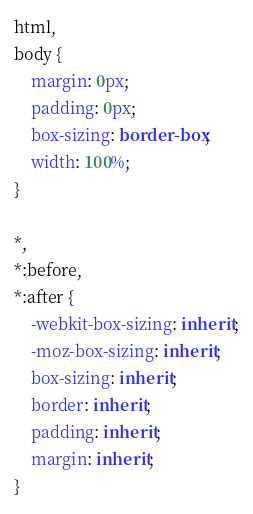Convert code to text. <code><loc_0><loc_0><loc_500><loc_500><_CSS_>
html,
body {
    margin: 0px;
    padding: 0px;
    box-sizing: border-box;
    width: 100%;
}

*,
*:before,
*:after {
    -webkit-box-sizing: inherit;
    -moz-box-sizing: inherit;
    box-sizing: inherit;
    border: inherit;
    padding: inherit;
    margin: inherit;
}</code> 